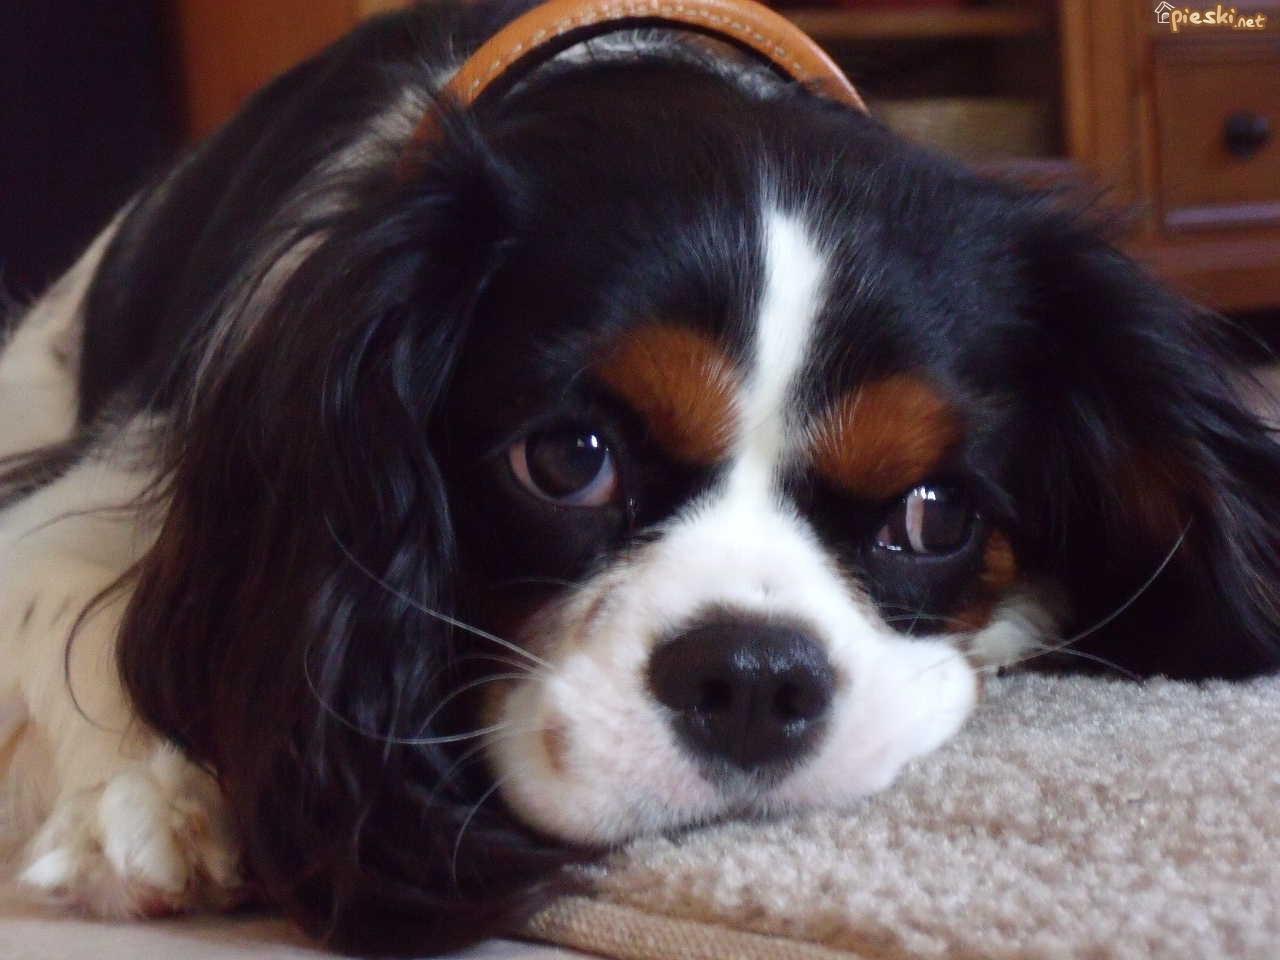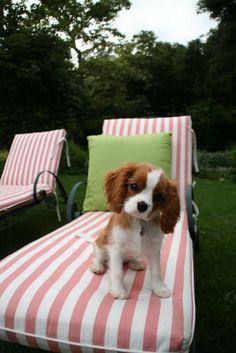The first image is the image on the left, the second image is the image on the right. For the images shown, is this caption "Two or more dogs are being held by one or more humans in one of the images." true? Answer yes or no. No. The first image is the image on the left, the second image is the image on the right. Examine the images to the left and right. Is the description "There are two dogs." accurate? Answer yes or no. Yes. 